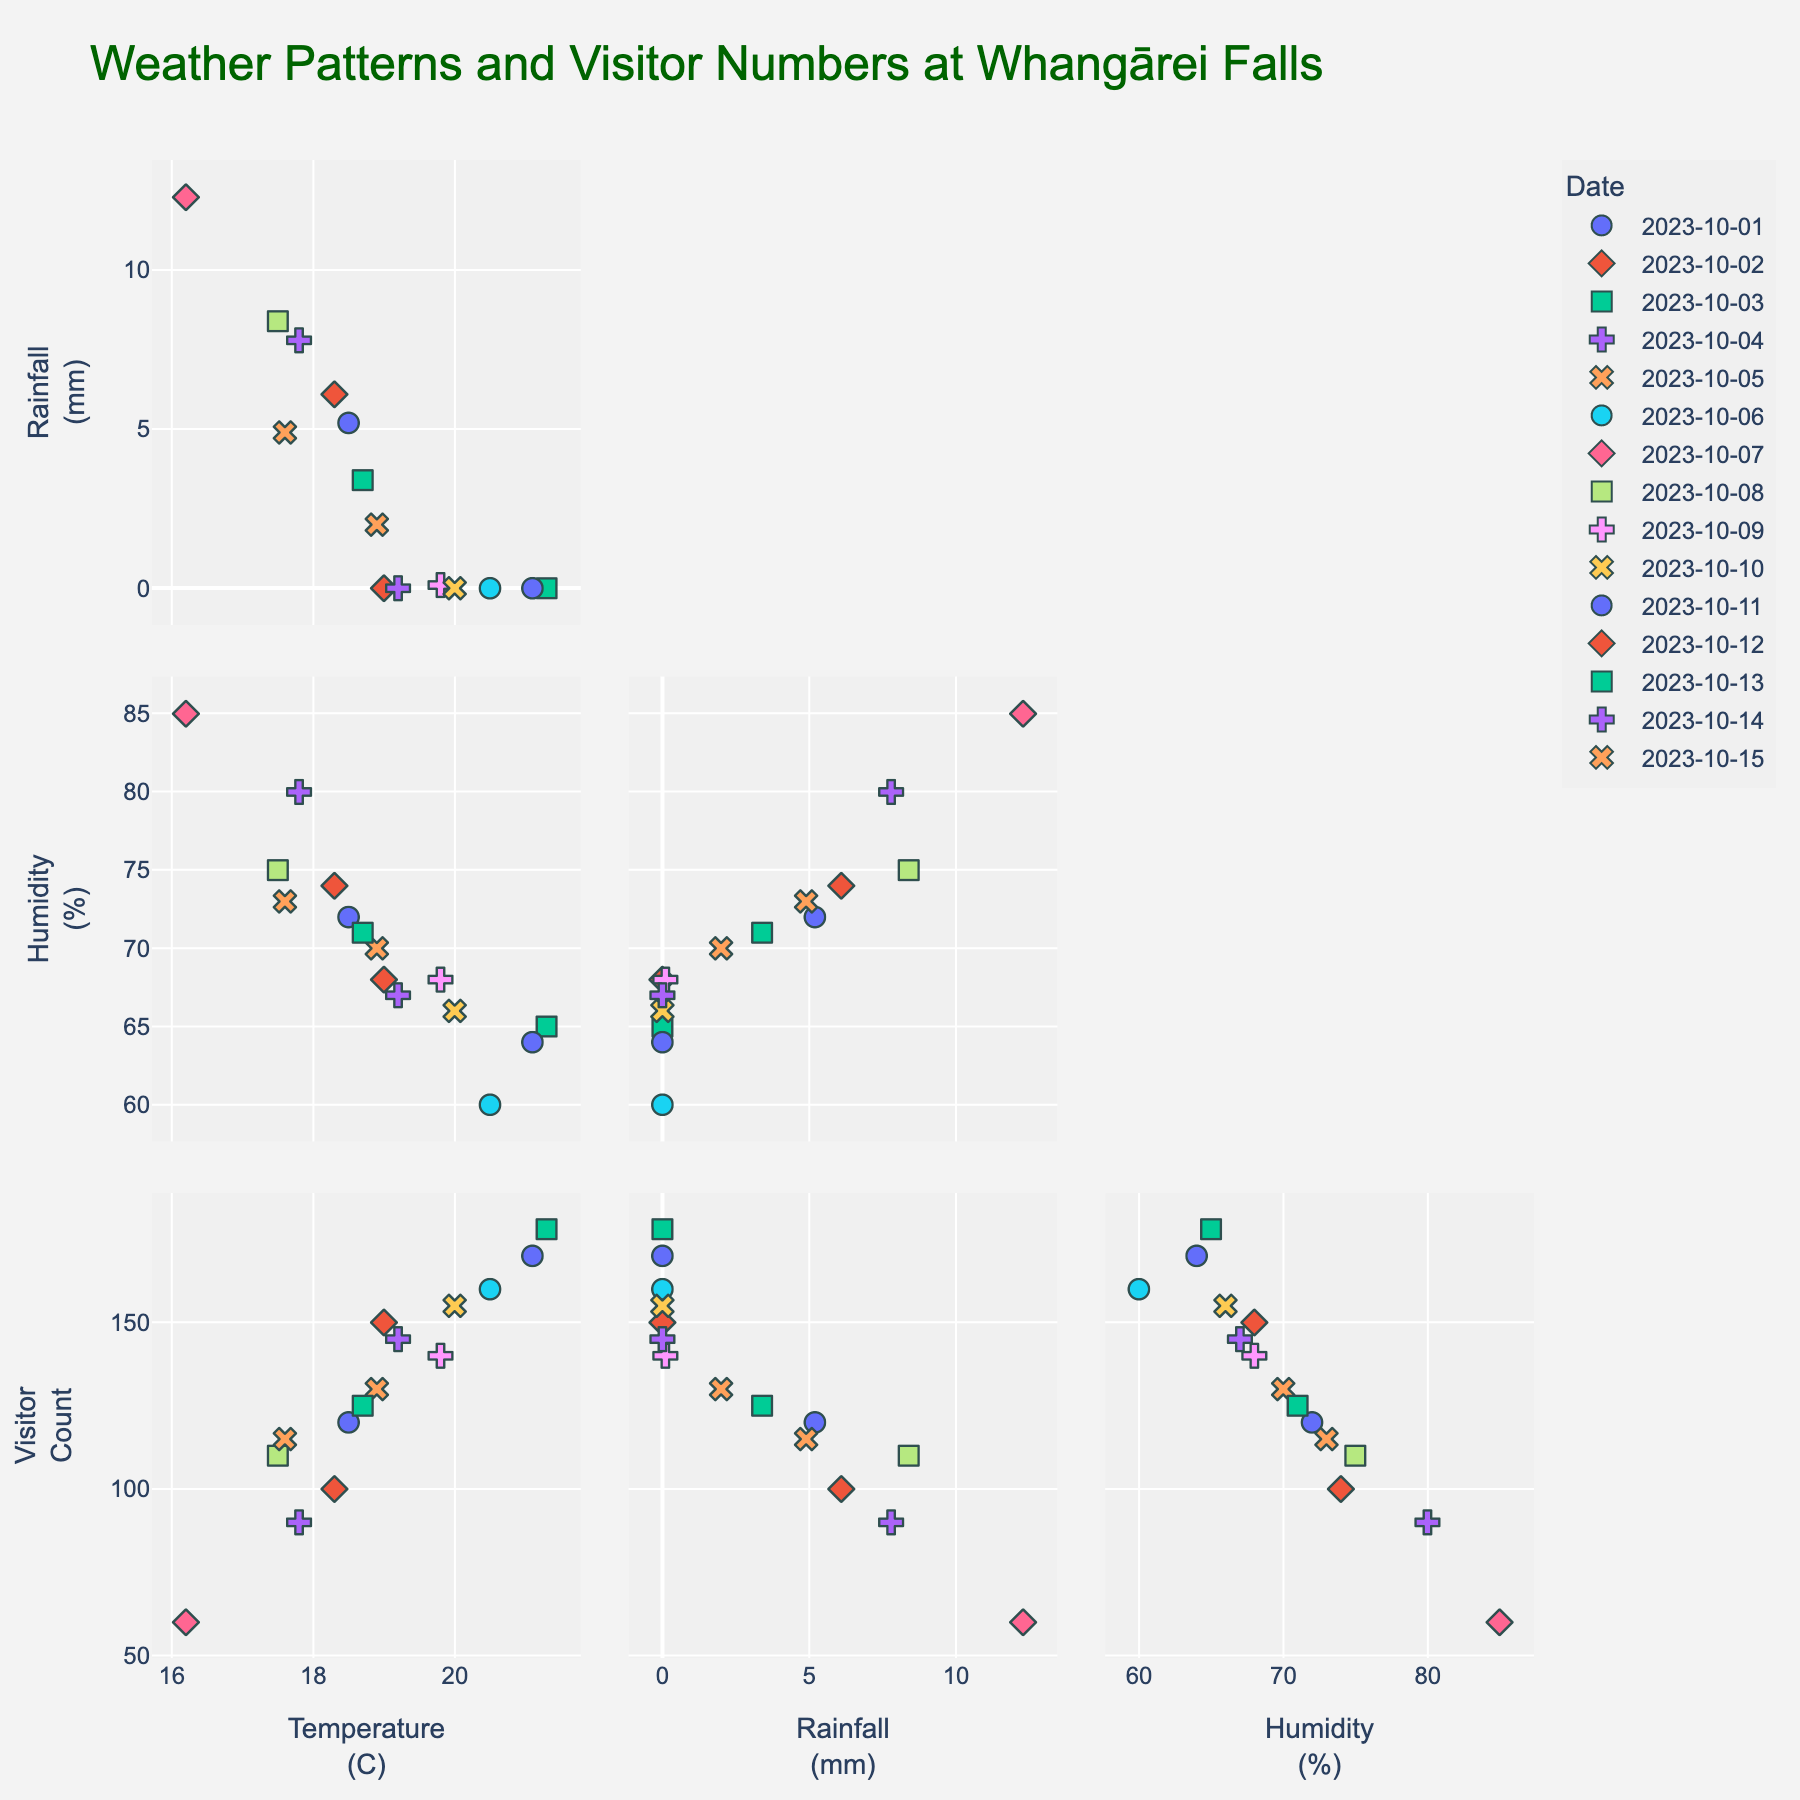What is the title of the figure? The title is usually displayed at the top of the figure. It provides an overview of what the figure is about. In this case, it states "Weather Patterns and Visitor Numbers at Whangārei Falls."
Answer: Weather Patterns and Visitor Numbers at Whangārei Falls How many data variables are included in the scatter plot matrix? The scatter plot matrix shows a grid of scatter plots for different combinations of variables. In this figure, the variables are 'Temperature (C)', 'Rainfall (mm)', 'Humidity (%)', and 'Visitor Count.' There are 4 variables.
Answer: 4 Which variable appears to have the strongest positive correlation with the 'Visitor Count'? You can determine this by looking at the scatter plots in the figure and seeing which one shows the most clear upward trend. The scatter plot of 'Temperature (C)' vs. 'Visitor Count' shows a clear positive correlation.
Answer: Temperature (C) On which date did the park receive the highest number of visitors? In the scatter plot matrix, look for the data point with the highest value on the vertical axis labeled 'Visitor Count.' The highest value appears on October 3, 2023, with 178 visitors.
Answer: October 3, 2023 Is there any visible relationship between 'Rainfall (mm)' and 'Visitor Count'? By examining the scatter plot of 'Rainfall (mm)' vs. 'Visitor Count,' one may notice that as rainfall increases, the visitor count generally decreases, indicating a negative correlation.
Answer: Negative correlation On which date was the highest rainfall recorded, and how many visitors were there on that day? Look at the scatter plots where 'Rainfall (mm)' is on the axis. Find the data point with the highest rainfall, which is October 7, 2023 (12.3 mm), and check the 'Visitor Count' on that day. It shows 60 visitors.
Answer: October 7, 2023, 60 visitors What can be inferred about visitor numbers on days with zero rainfall? Check the scatter plots where 'Rainfall (mm)' is plotted against 'Visitor Count' and identify the data points where rainfall is zero. The data points generally show higher visitor counts on days with zero rainfall.
Answer: Higher visitor counts Which variable shows the least correlation with 'Visitor Count'? Examine the scatter plots for each variable against 'Visitor Count.' 'Humidity (%)' appears to have the least correlation with 'Visitor Count' because the data points are more scattered and do not show a clear trend.
Answer: Humidity (%) How does 'Temperature (C)' tend to affect 'Humidity (%)'? Look at the scatter plot for 'Temperature (C)' vs. 'Humidity (%).' The data points show a slight negative trend, indicating that as temperature increases, humidity tends to decrease.
Answer: Negative trend What is the range of 'Visitor Count' values captured in the scatter plot matrix? Examine the 'Visitor Count' axis across the scatter plots. The minimum visitor count is 60, and the maximum is 178.
Answer: 60 to 178 